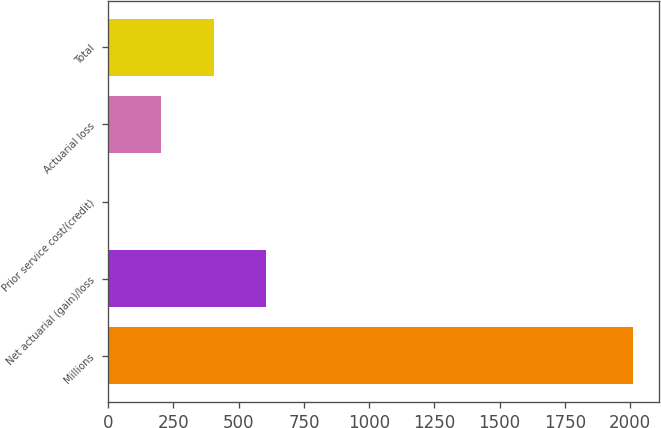Convert chart to OTSL. <chart><loc_0><loc_0><loc_500><loc_500><bar_chart><fcel>Millions<fcel>Net actuarial (gain)/loss<fcel>Prior service cost/(credit)<fcel>Actuarial loss<fcel>Total<nl><fcel>2010<fcel>605.1<fcel>3<fcel>203.7<fcel>404.4<nl></chart> 